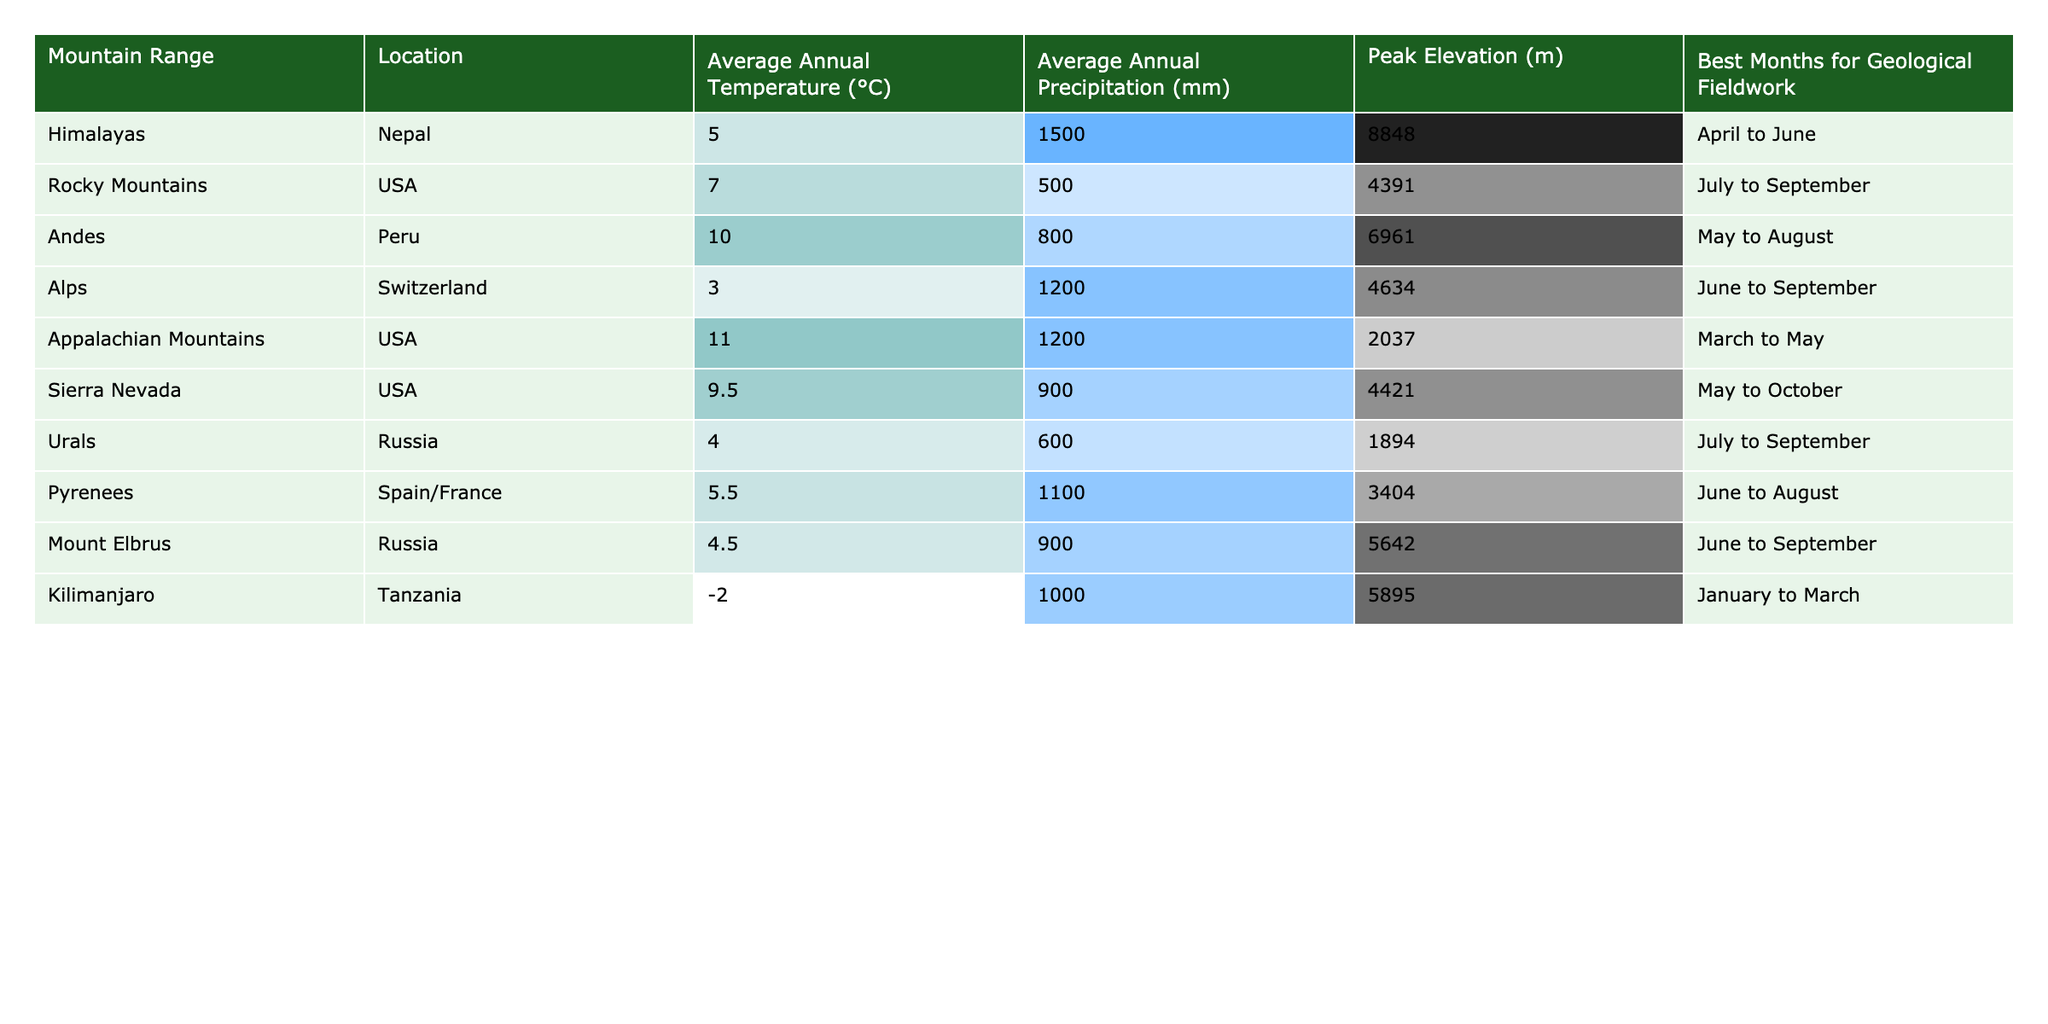What is the average annual temperature of the Andes? The average annual temperature of the Andes, as shown in the table, is listed under the corresponding column next to its row. This value is 10.0 °C.
Answer: 10.0 °C Which mountain range has the highest peak elevation? The highest peak elevation is represented in the table, which corresponds to the Himalayas at an elevation of 8848 m.
Answer: 8848 m What are the best months for geological fieldwork in the Rocky Mountains? Looking at the specific row for the Rocky Mountains in the table, it states that the best months for geological fieldwork are July to September.
Answer: July to September Is the average annual precipitation for the Alps greater than that of the Urals? The average annual precipitation for the Alps is 1200 mm, while for the Urals, it is 600 mm. Since 1200 mm is greater than 600 mm, the statement is true.
Answer: Yes What is the difference in average annual temperature between the Appalachian Mountains and Kilimanjaro? The average annual temperature for the Appalachian Mountains is 11.0 °C, and for Kilimanjaro, it is -2.0 °C. To find the difference, subtract: 11.0 - (-2.0) = 11.0 + 2.0 = 13.0 °C.
Answer: 13.0 °C Which mountain range has the most months suitable for geological fieldwork? The Sierra Nevada has the longest range mentioned for suitable geological fieldwork, which is from May to October (6 months), compared to the other ranges that each have shorter durations.
Answer: Sierra Nevada What is the average annual temperature of the mountain ranges listed with elevations over 5000 meters? The mountain ranges with elevations over 5000 meters are the Andes (10.0 °C) and Kilimanjaro (-2.0 °C). To find the average, we calculate (10.0 + (-2.0)) / 2 = 8.0 °C.
Answer: 8.0 °C Does the method for geological fieldwork differ by mountain range? The best months for geological fieldwork vary across different mountain ranges, which implies differing methods or conditions suited for each range. However, the data does not provide specific methods.
Answer: Yes How many mountain ranges have an average annual temperature below 5.0 °C? From the table, there are three mountain ranges with an average annual temperature below 5.0 °C: the Himalayas (5.0 °C), Alps (3.0 °C), and Urals (4.0 °C).
Answer: 2 What is the relationship between peak elevation and average annual precipitation in this dataset? Observing the data, there is no clear correlation between the two variables as different peak elevations have varying precipitation values, indicating varied geographical and atmospheric conditions impacting both metrics.
Answer: No clear correlation 